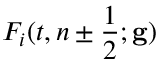<formula> <loc_0><loc_0><loc_500><loc_500>F _ { i } ( t , n \pm \frac { 1 } { 2 } ; g )</formula> 